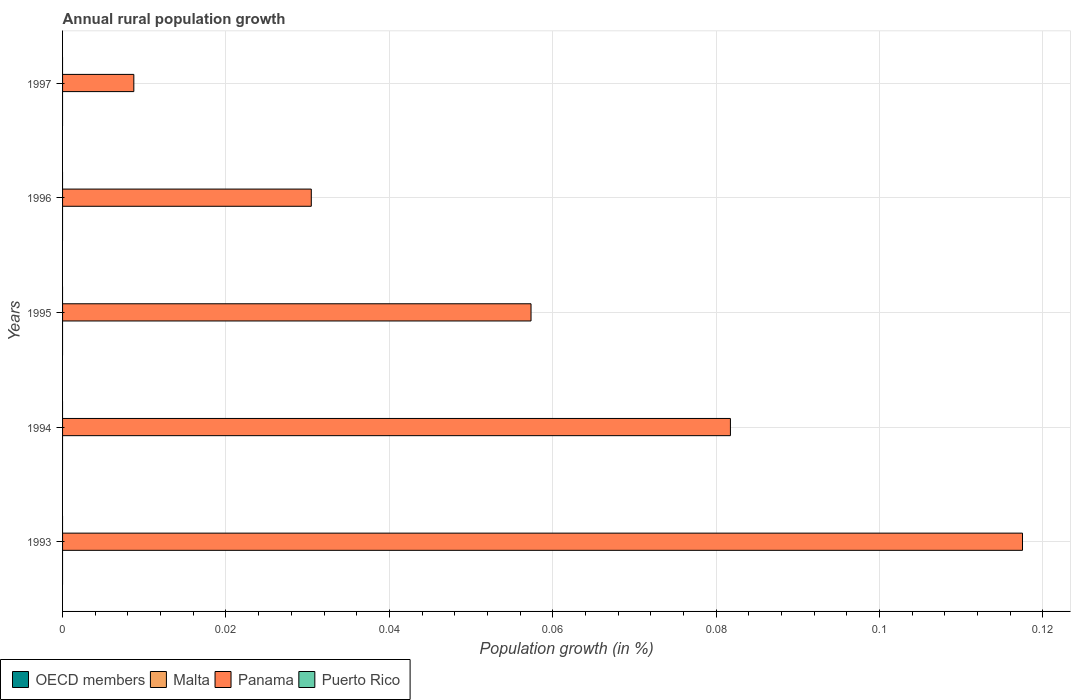How many different coloured bars are there?
Your answer should be very brief. 1. How many bars are there on the 2nd tick from the top?
Keep it short and to the point. 1. Across all years, what is the maximum percentage of rural population growth in Panama?
Keep it short and to the point. 0.12. Across all years, what is the minimum percentage of rural population growth in Panama?
Ensure brevity in your answer.  0.01. What is the total percentage of rural population growth in Panama in the graph?
Ensure brevity in your answer.  0.3. What is the difference between the percentage of rural population growth in Panama in 1996 and that in 1997?
Your response must be concise. 0.02. What is the difference between the percentage of rural population growth in OECD members in 1994 and the percentage of rural population growth in Panama in 1997?
Ensure brevity in your answer.  -0.01. In how many years, is the percentage of rural population growth in Malta greater than 0.092 %?
Provide a succinct answer. 0. What is the ratio of the percentage of rural population growth in Panama in 1994 to that in 1997?
Your answer should be compact. 9.37. Is the percentage of rural population growth in Panama in 1993 less than that in 1994?
Offer a terse response. No. What is the difference between the highest and the second highest percentage of rural population growth in Panama?
Your response must be concise. 0.04. What is the difference between the highest and the lowest percentage of rural population growth in Panama?
Your answer should be compact. 0.11. In how many years, is the percentage of rural population growth in Malta greater than the average percentage of rural population growth in Malta taken over all years?
Your response must be concise. 0. Is the sum of the percentage of rural population growth in Panama in 1993 and 1997 greater than the maximum percentage of rural population growth in Malta across all years?
Offer a terse response. Yes. Is it the case that in every year, the sum of the percentage of rural population growth in Puerto Rico and percentage of rural population growth in Malta is greater than the percentage of rural population growth in Panama?
Offer a terse response. No. How many bars are there?
Your answer should be compact. 5. Are all the bars in the graph horizontal?
Make the answer very short. Yes. Does the graph contain any zero values?
Make the answer very short. Yes. Does the graph contain grids?
Your answer should be compact. Yes. How are the legend labels stacked?
Your response must be concise. Horizontal. What is the title of the graph?
Offer a terse response. Annual rural population growth. Does "Heavily indebted poor countries" appear as one of the legend labels in the graph?
Your answer should be compact. No. What is the label or title of the X-axis?
Make the answer very short. Population growth (in %). What is the Population growth (in %) of Panama in 1993?
Your response must be concise. 0.12. What is the Population growth (in %) in Puerto Rico in 1993?
Offer a very short reply. 0. What is the Population growth (in %) in OECD members in 1994?
Offer a terse response. 0. What is the Population growth (in %) of Malta in 1994?
Offer a very short reply. 0. What is the Population growth (in %) in Panama in 1994?
Make the answer very short. 0.08. What is the Population growth (in %) of Malta in 1995?
Keep it short and to the point. 0. What is the Population growth (in %) of Panama in 1995?
Make the answer very short. 0.06. What is the Population growth (in %) in Malta in 1996?
Keep it short and to the point. 0. What is the Population growth (in %) of Panama in 1996?
Provide a succinct answer. 0.03. What is the Population growth (in %) in OECD members in 1997?
Give a very brief answer. 0. What is the Population growth (in %) in Panama in 1997?
Provide a short and direct response. 0.01. What is the Population growth (in %) in Puerto Rico in 1997?
Your response must be concise. 0. Across all years, what is the maximum Population growth (in %) of Panama?
Offer a terse response. 0.12. Across all years, what is the minimum Population growth (in %) of Panama?
Your answer should be very brief. 0.01. What is the total Population growth (in %) of Malta in the graph?
Provide a succinct answer. 0. What is the total Population growth (in %) of Panama in the graph?
Provide a short and direct response. 0.3. What is the total Population growth (in %) of Puerto Rico in the graph?
Make the answer very short. 0. What is the difference between the Population growth (in %) of Panama in 1993 and that in 1994?
Make the answer very short. 0.04. What is the difference between the Population growth (in %) in Panama in 1993 and that in 1995?
Offer a terse response. 0.06. What is the difference between the Population growth (in %) of Panama in 1993 and that in 1996?
Make the answer very short. 0.09. What is the difference between the Population growth (in %) in Panama in 1993 and that in 1997?
Make the answer very short. 0.11. What is the difference between the Population growth (in %) in Panama in 1994 and that in 1995?
Offer a terse response. 0.02. What is the difference between the Population growth (in %) of Panama in 1994 and that in 1996?
Provide a succinct answer. 0.05. What is the difference between the Population growth (in %) in Panama in 1994 and that in 1997?
Your answer should be compact. 0.07. What is the difference between the Population growth (in %) of Panama in 1995 and that in 1996?
Give a very brief answer. 0.03. What is the difference between the Population growth (in %) of Panama in 1995 and that in 1997?
Your answer should be compact. 0.05. What is the difference between the Population growth (in %) in Panama in 1996 and that in 1997?
Provide a succinct answer. 0.02. What is the average Population growth (in %) of OECD members per year?
Offer a very short reply. 0. What is the average Population growth (in %) of Panama per year?
Keep it short and to the point. 0.06. What is the ratio of the Population growth (in %) in Panama in 1993 to that in 1994?
Your answer should be very brief. 1.44. What is the ratio of the Population growth (in %) of Panama in 1993 to that in 1995?
Your answer should be compact. 2.05. What is the ratio of the Population growth (in %) in Panama in 1993 to that in 1996?
Provide a succinct answer. 3.86. What is the ratio of the Population growth (in %) in Panama in 1993 to that in 1997?
Your answer should be compact. 13.47. What is the ratio of the Population growth (in %) of Panama in 1994 to that in 1995?
Provide a short and direct response. 1.43. What is the ratio of the Population growth (in %) of Panama in 1994 to that in 1996?
Provide a succinct answer. 2.69. What is the ratio of the Population growth (in %) of Panama in 1994 to that in 1997?
Keep it short and to the point. 9.37. What is the ratio of the Population growth (in %) in Panama in 1995 to that in 1996?
Make the answer very short. 1.88. What is the ratio of the Population growth (in %) of Panama in 1995 to that in 1997?
Offer a very short reply. 6.57. What is the ratio of the Population growth (in %) of Panama in 1996 to that in 1997?
Offer a terse response. 3.49. What is the difference between the highest and the second highest Population growth (in %) in Panama?
Ensure brevity in your answer.  0.04. What is the difference between the highest and the lowest Population growth (in %) in Panama?
Your answer should be very brief. 0.11. 